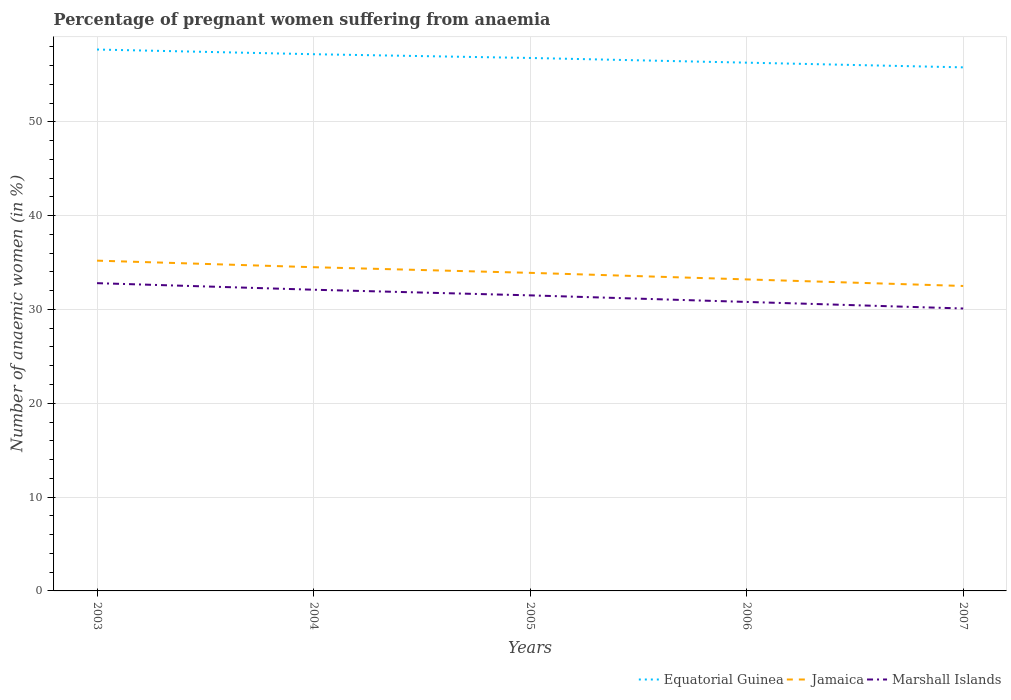How many different coloured lines are there?
Your answer should be very brief. 3. Is the number of lines equal to the number of legend labels?
Provide a short and direct response. Yes. Across all years, what is the maximum number of anaemic women in Jamaica?
Make the answer very short. 32.5. What is the difference between the highest and the second highest number of anaemic women in Equatorial Guinea?
Make the answer very short. 1.9. What is the difference between the highest and the lowest number of anaemic women in Jamaica?
Your answer should be compact. 3. How many lines are there?
Make the answer very short. 3. How many years are there in the graph?
Your answer should be very brief. 5. Are the values on the major ticks of Y-axis written in scientific E-notation?
Provide a short and direct response. No. Does the graph contain any zero values?
Provide a short and direct response. No. Does the graph contain grids?
Make the answer very short. Yes. Where does the legend appear in the graph?
Offer a very short reply. Bottom right. What is the title of the graph?
Keep it short and to the point. Percentage of pregnant women suffering from anaemia. Does "Latin America(all income levels)" appear as one of the legend labels in the graph?
Ensure brevity in your answer.  No. What is the label or title of the X-axis?
Offer a very short reply. Years. What is the label or title of the Y-axis?
Keep it short and to the point. Number of anaemic women (in %). What is the Number of anaemic women (in %) of Equatorial Guinea in 2003?
Your response must be concise. 57.7. What is the Number of anaemic women (in %) of Jamaica in 2003?
Offer a very short reply. 35.2. What is the Number of anaemic women (in %) in Marshall Islands in 2003?
Give a very brief answer. 32.8. What is the Number of anaemic women (in %) in Equatorial Guinea in 2004?
Keep it short and to the point. 57.2. What is the Number of anaemic women (in %) of Jamaica in 2004?
Provide a succinct answer. 34.5. What is the Number of anaemic women (in %) of Marshall Islands in 2004?
Give a very brief answer. 32.1. What is the Number of anaemic women (in %) in Equatorial Guinea in 2005?
Provide a short and direct response. 56.8. What is the Number of anaemic women (in %) in Jamaica in 2005?
Ensure brevity in your answer.  33.9. What is the Number of anaemic women (in %) in Marshall Islands in 2005?
Provide a succinct answer. 31.5. What is the Number of anaemic women (in %) in Equatorial Guinea in 2006?
Provide a short and direct response. 56.3. What is the Number of anaemic women (in %) of Jamaica in 2006?
Ensure brevity in your answer.  33.2. What is the Number of anaemic women (in %) in Marshall Islands in 2006?
Your response must be concise. 30.8. What is the Number of anaemic women (in %) of Equatorial Guinea in 2007?
Your answer should be compact. 55.8. What is the Number of anaemic women (in %) in Jamaica in 2007?
Offer a terse response. 32.5. What is the Number of anaemic women (in %) in Marshall Islands in 2007?
Your answer should be compact. 30.1. Across all years, what is the maximum Number of anaemic women (in %) of Equatorial Guinea?
Keep it short and to the point. 57.7. Across all years, what is the maximum Number of anaemic women (in %) in Jamaica?
Provide a short and direct response. 35.2. Across all years, what is the maximum Number of anaemic women (in %) in Marshall Islands?
Provide a short and direct response. 32.8. Across all years, what is the minimum Number of anaemic women (in %) of Equatorial Guinea?
Your response must be concise. 55.8. Across all years, what is the minimum Number of anaemic women (in %) in Jamaica?
Keep it short and to the point. 32.5. Across all years, what is the minimum Number of anaemic women (in %) in Marshall Islands?
Provide a succinct answer. 30.1. What is the total Number of anaemic women (in %) of Equatorial Guinea in the graph?
Your answer should be compact. 283.8. What is the total Number of anaemic women (in %) in Jamaica in the graph?
Offer a very short reply. 169.3. What is the total Number of anaemic women (in %) of Marshall Islands in the graph?
Your answer should be very brief. 157.3. What is the difference between the Number of anaemic women (in %) in Jamaica in 2003 and that in 2004?
Ensure brevity in your answer.  0.7. What is the difference between the Number of anaemic women (in %) of Marshall Islands in 2003 and that in 2005?
Your answer should be compact. 1.3. What is the difference between the Number of anaemic women (in %) of Equatorial Guinea in 2003 and that in 2006?
Keep it short and to the point. 1.4. What is the difference between the Number of anaemic women (in %) of Jamaica in 2003 and that in 2006?
Keep it short and to the point. 2. What is the difference between the Number of anaemic women (in %) of Jamaica in 2003 and that in 2007?
Your answer should be compact. 2.7. What is the difference between the Number of anaemic women (in %) in Equatorial Guinea in 2004 and that in 2005?
Provide a short and direct response. 0.4. What is the difference between the Number of anaemic women (in %) in Marshall Islands in 2004 and that in 2005?
Offer a terse response. 0.6. What is the difference between the Number of anaemic women (in %) in Equatorial Guinea in 2004 and that in 2006?
Your answer should be very brief. 0.9. What is the difference between the Number of anaemic women (in %) in Equatorial Guinea in 2004 and that in 2007?
Your answer should be compact. 1.4. What is the difference between the Number of anaemic women (in %) in Jamaica in 2004 and that in 2007?
Ensure brevity in your answer.  2. What is the difference between the Number of anaemic women (in %) of Marshall Islands in 2004 and that in 2007?
Keep it short and to the point. 2. What is the difference between the Number of anaemic women (in %) of Equatorial Guinea in 2005 and that in 2006?
Provide a short and direct response. 0.5. What is the difference between the Number of anaemic women (in %) of Equatorial Guinea in 2005 and that in 2007?
Your answer should be very brief. 1. What is the difference between the Number of anaemic women (in %) of Marshall Islands in 2005 and that in 2007?
Provide a short and direct response. 1.4. What is the difference between the Number of anaemic women (in %) of Equatorial Guinea in 2006 and that in 2007?
Ensure brevity in your answer.  0.5. What is the difference between the Number of anaemic women (in %) of Equatorial Guinea in 2003 and the Number of anaemic women (in %) of Jamaica in 2004?
Provide a succinct answer. 23.2. What is the difference between the Number of anaemic women (in %) in Equatorial Guinea in 2003 and the Number of anaemic women (in %) in Marshall Islands in 2004?
Ensure brevity in your answer.  25.6. What is the difference between the Number of anaemic women (in %) in Equatorial Guinea in 2003 and the Number of anaemic women (in %) in Jamaica in 2005?
Ensure brevity in your answer.  23.8. What is the difference between the Number of anaemic women (in %) of Equatorial Guinea in 2003 and the Number of anaemic women (in %) of Marshall Islands in 2005?
Keep it short and to the point. 26.2. What is the difference between the Number of anaemic women (in %) of Equatorial Guinea in 2003 and the Number of anaemic women (in %) of Marshall Islands in 2006?
Offer a terse response. 26.9. What is the difference between the Number of anaemic women (in %) of Jamaica in 2003 and the Number of anaemic women (in %) of Marshall Islands in 2006?
Your answer should be very brief. 4.4. What is the difference between the Number of anaemic women (in %) of Equatorial Guinea in 2003 and the Number of anaemic women (in %) of Jamaica in 2007?
Provide a succinct answer. 25.2. What is the difference between the Number of anaemic women (in %) of Equatorial Guinea in 2003 and the Number of anaemic women (in %) of Marshall Islands in 2007?
Give a very brief answer. 27.6. What is the difference between the Number of anaemic women (in %) in Equatorial Guinea in 2004 and the Number of anaemic women (in %) in Jamaica in 2005?
Keep it short and to the point. 23.3. What is the difference between the Number of anaemic women (in %) in Equatorial Guinea in 2004 and the Number of anaemic women (in %) in Marshall Islands in 2005?
Offer a very short reply. 25.7. What is the difference between the Number of anaemic women (in %) in Jamaica in 2004 and the Number of anaemic women (in %) in Marshall Islands in 2005?
Make the answer very short. 3. What is the difference between the Number of anaemic women (in %) of Equatorial Guinea in 2004 and the Number of anaemic women (in %) of Jamaica in 2006?
Offer a terse response. 24. What is the difference between the Number of anaemic women (in %) in Equatorial Guinea in 2004 and the Number of anaemic women (in %) in Marshall Islands in 2006?
Your response must be concise. 26.4. What is the difference between the Number of anaemic women (in %) in Equatorial Guinea in 2004 and the Number of anaemic women (in %) in Jamaica in 2007?
Offer a very short reply. 24.7. What is the difference between the Number of anaemic women (in %) in Equatorial Guinea in 2004 and the Number of anaemic women (in %) in Marshall Islands in 2007?
Your answer should be very brief. 27.1. What is the difference between the Number of anaemic women (in %) in Equatorial Guinea in 2005 and the Number of anaemic women (in %) in Jamaica in 2006?
Make the answer very short. 23.6. What is the difference between the Number of anaemic women (in %) of Equatorial Guinea in 2005 and the Number of anaemic women (in %) of Marshall Islands in 2006?
Ensure brevity in your answer.  26. What is the difference between the Number of anaemic women (in %) of Jamaica in 2005 and the Number of anaemic women (in %) of Marshall Islands in 2006?
Provide a succinct answer. 3.1. What is the difference between the Number of anaemic women (in %) of Equatorial Guinea in 2005 and the Number of anaemic women (in %) of Jamaica in 2007?
Your answer should be very brief. 24.3. What is the difference between the Number of anaemic women (in %) in Equatorial Guinea in 2005 and the Number of anaemic women (in %) in Marshall Islands in 2007?
Ensure brevity in your answer.  26.7. What is the difference between the Number of anaemic women (in %) in Equatorial Guinea in 2006 and the Number of anaemic women (in %) in Jamaica in 2007?
Make the answer very short. 23.8. What is the difference between the Number of anaemic women (in %) of Equatorial Guinea in 2006 and the Number of anaemic women (in %) of Marshall Islands in 2007?
Your response must be concise. 26.2. What is the average Number of anaemic women (in %) in Equatorial Guinea per year?
Offer a terse response. 56.76. What is the average Number of anaemic women (in %) in Jamaica per year?
Offer a terse response. 33.86. What is the average Number of anaemic women (in %) in Marshall Islands per year?
Provide a succinct answer. 31.46. In the year 2003, what is the difference between the Number of anaemic women (in %) in Equatorial Guinea and Number of anaemic women (in %) in Marshall Islands?
Make the answer very short. 24.9. In the year 2003, what is the difference between the Number of anaemic women (in %) in Jamaica and Number of anaemic women (in %) in Marshall Islands?
Your response must be concise. 2.4. In the year 2004, what is the difference between the Number of anaemic women (in %) of Equatorial Guinea and Number of anaemic women (in %) of Jamaica?
Your answer should be very brief. 22.7. In the year 2004, what is the difference between the Number of anaemic women (in %) in Equatorial Guinea and Number of anaemic women (in %) in Marshall Islands?
Your answer should be compact. 25.1. In the year 2004, what is the difference between the Number of anaemic women (in %) in Jamaica and Number of anaemic women (in %) in Marshall Islands?
Provide a succinct answer. 2.4. In the year 2005, what is the difference between the Number of anaemic women (in %) of Equatorial Guinea and Number of anaemic women (in %) of Jamaica?
Keep it short and to the point. 22.9. In the year 2005, what is the difference between the Number of anaemic women (in %) of Equatorial Guinea and Number of anaemic women (in %) of Marshall Islands?
Offer a very short reply. 25.3. In the year 2005, what is the difference between the Number of anaemic women (in %) in Jamaica and Number of anaemic women (in %) in Marshall Islands?
Your response must be concise. 2.4. In the year 2006, what is the difference between the Number of anaemic women (in %) of Equatorial Guinea and Number of anaemic women (in %) of Jamaica?
Offer a terse response. 23.1. In the year 2006, what is the difference between the Number of anaemic women (in %) in Equatorial Guinea and Number of anaemic women (in %) in Marshall Islands?
Your response must be concise. 25.5. In the year 2006, what is the difference between the Number of anaemic women (in %) in Jamaica and Number of anaemic women (in %) in Marshall Islands?
Keep it short and to the point. 2.4. In the year 2007, what is the difference between the Number of anaemic women (in %) in Equatorial Guinea and Number of anaemic women (in %) in Jamaica?
Your response must be concise. 23.3. In the year 2007, what is the difference between the Number of anaemic women (in %) of Equatorial Guinea and Number of anaemic women (in %) of Marshall Islands?
Provide a short and direct response. 25.7. What is the ratio of the Number of anaemic women (in %) in Equatorial Guinea in 2003 to that in 2004?
Provide a succinct answer. 1.01. What is the ratio of the Number of anaemic women (in %) in Jamaica in 2003 to that in 2004?
Give a very brief answer. 1.02. What is the ratio of the Number of anaemic women (in %) in Marshall Islands in 2003 to that in 2004?
Your response must be concise. 1.02. What is the ratio of the Number of anaemic women (in %) of Equatorial Guinea in 2003 to that in 2005?
Your answer should be very brief. 1.02. What is the ratio of the Number of anaemic women (in %) in Jamaica in 2003 to that in 2005?
Your response must be concise. 1.04. What is the ratio of the Number of anaemic women (in %) of Marshall Islands in 2003 to that in 2005?
Your response must be concise. 1.04. What is the ratio of the Number of anaemic women (in %) of Equatorial Guinea in 2003 to that in 2006?
Keep it short and to the point. 1.02. What is the ratio of the Number of anaemic women (in %) of Jamaica in 2003 to that in 2006?
Give a very brief answer. 1.06. What is the ratio of the Number of anaemic women (in %) in Marshall Islands in 2003 to that in 2006?
Offer a very short reply. 1.06. What is the ratio of the Number of anaemic women (in %) of Equatorial Guinea in 2003 to that in 2007?
Your answer should be very brief. 1.03. What is the ratio of the Number of anaemic women (in %) of Jamaica in 2003 to that in 2007?
Provide a succinct answer. 1.08. What is the ratio of the Number of anaemic women (in %) of Marshall Islands in 2003 to that in 2007?
Ensure brevity in your answer.  1.09. What is the ratio of the Number of anaemic women (in %) in Equatorial Guinea in 2004 to that in 2005?
Keep it short and to the point. 1.01. What is the ratio of the Number of anaemic women (in %) in Jamaica in 2004 to that in 2005?
Give a very brief answer. 1.02. What is the ratio of the Number of anaemic women (in %) in Marshall Islands in 2004 to that in 2005?
Keep it short and to the point. 1.02. What is the ratio of the Number of anaemic women (in %) in Jamaica in 2004 to that in 2006?
Your response must be concise. 1.04. What is the ratio of the Number of anaemic women (in %) in Marshall Islands in 2004 to that in 2006?
Ensure brevity in your answer.  1.04. What is the ratio of the Number of anaemic women (in %) of Equatorial Guinea in 2004 to that in 2007?
Ensure brevity in your answer.  1.03. What is the ratio of the Number of anaemic women (in %) of Jamaica in 2004 to that in 2007?
Keep it short and to the point. 1.06. What is the ratio of the Number of anaemic women (in %) of Marshall Islands in 2004 to that in 2007?
Provide a succinct answer. 1.07. What is the ratio of the Number of anaemic women (in %) of Equatorial Guinea in 2005 to that in 2006?
Provide a succinct answer. 1.01. What is the ratio of the Number of anaemic women (in %) of Jamaica in 2005 to that in 2006?
Your answer should be compact. 1.02. What is the ratio of the Number of anaemic women (in %) of Marshall Islands in 2005 to that in 2006?
Your answer should be very brief. 1.02. What is the ratio of the Number of anaemic women (in %) of Equatorial Guinea in 2005 to that in 2007?
Your response must be concise. 1.02. What is the ratio of the Number of anaemic women (in %) of Jamaica in 2005 to that in 2007?
Offer a very short reply. 1.04. What is the ratio of the Number of anaemic women (in %) of Marshall Islands in 2005 to that in 2007?
Offer a terse response. 1.05. What is the ratio of the Number of anaemic women (in %) of Jamaica in 2006 to that in 2007?
Your response must be concise. 1.02. What is the ratio of the Number of anaemic women (in %) of Marshall Islands in 2006 to that in 2007?
Make the answer very short. 1.02. What is the difference between the highest and the second highest Number of anaemic women (in %) of Equatorial Guinea?
Keep it short and to the point. 0.5. What is the difference between the highest and the lowest Number of anaemic women (in %) of Equatorial Guinea?
Keep it short and to the point. 1.9. What is the difference between the highest and the lowest Number of anaemic women (in %) of Marshall Islands?
Make the answer very short. 2.7. 